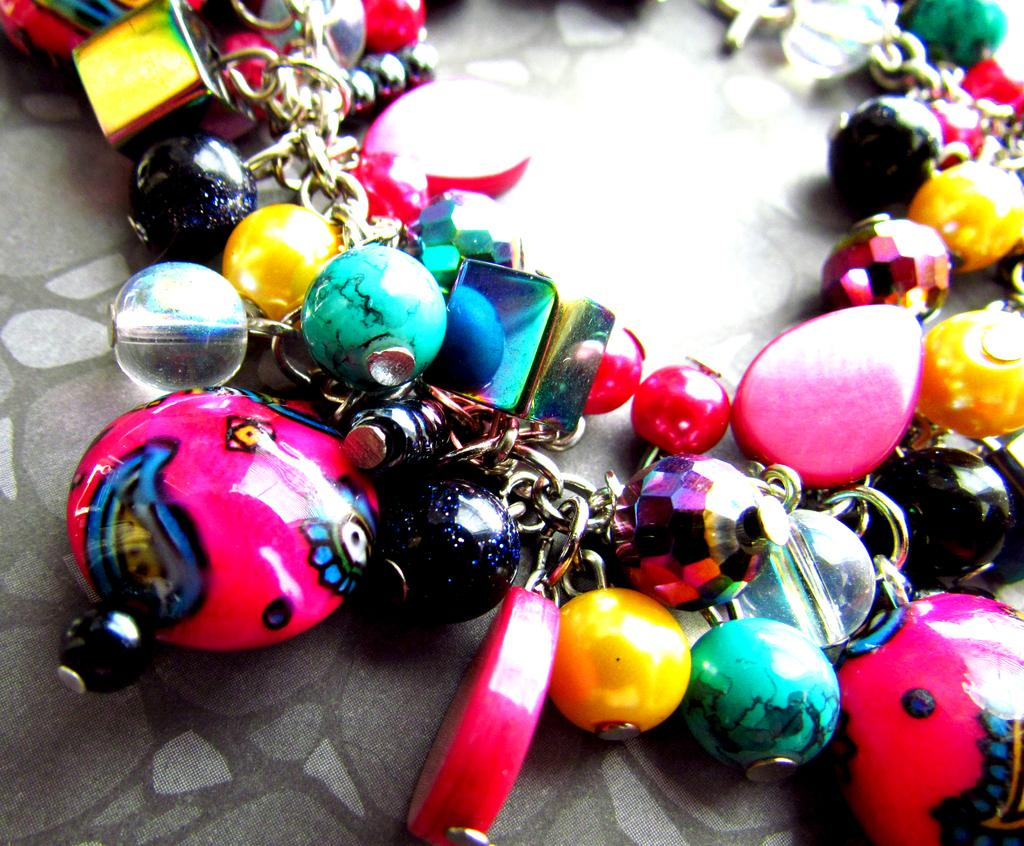What type of object is shown in the image? The object is a bracelet. What can be observed about the design of the bracelet? The bracelet has many colorful beads. What type of garden can be seen in the background of the image? There is no garden present in the image; it only features a bracelet with colorful beads. 